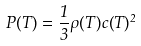<formula> <loc_0><loc_0><loc_500><loc_500>P ( T ) = \frac { 1 } { 3 } \rho ( T ) c ( T ) ^ { 2 }</formula> 